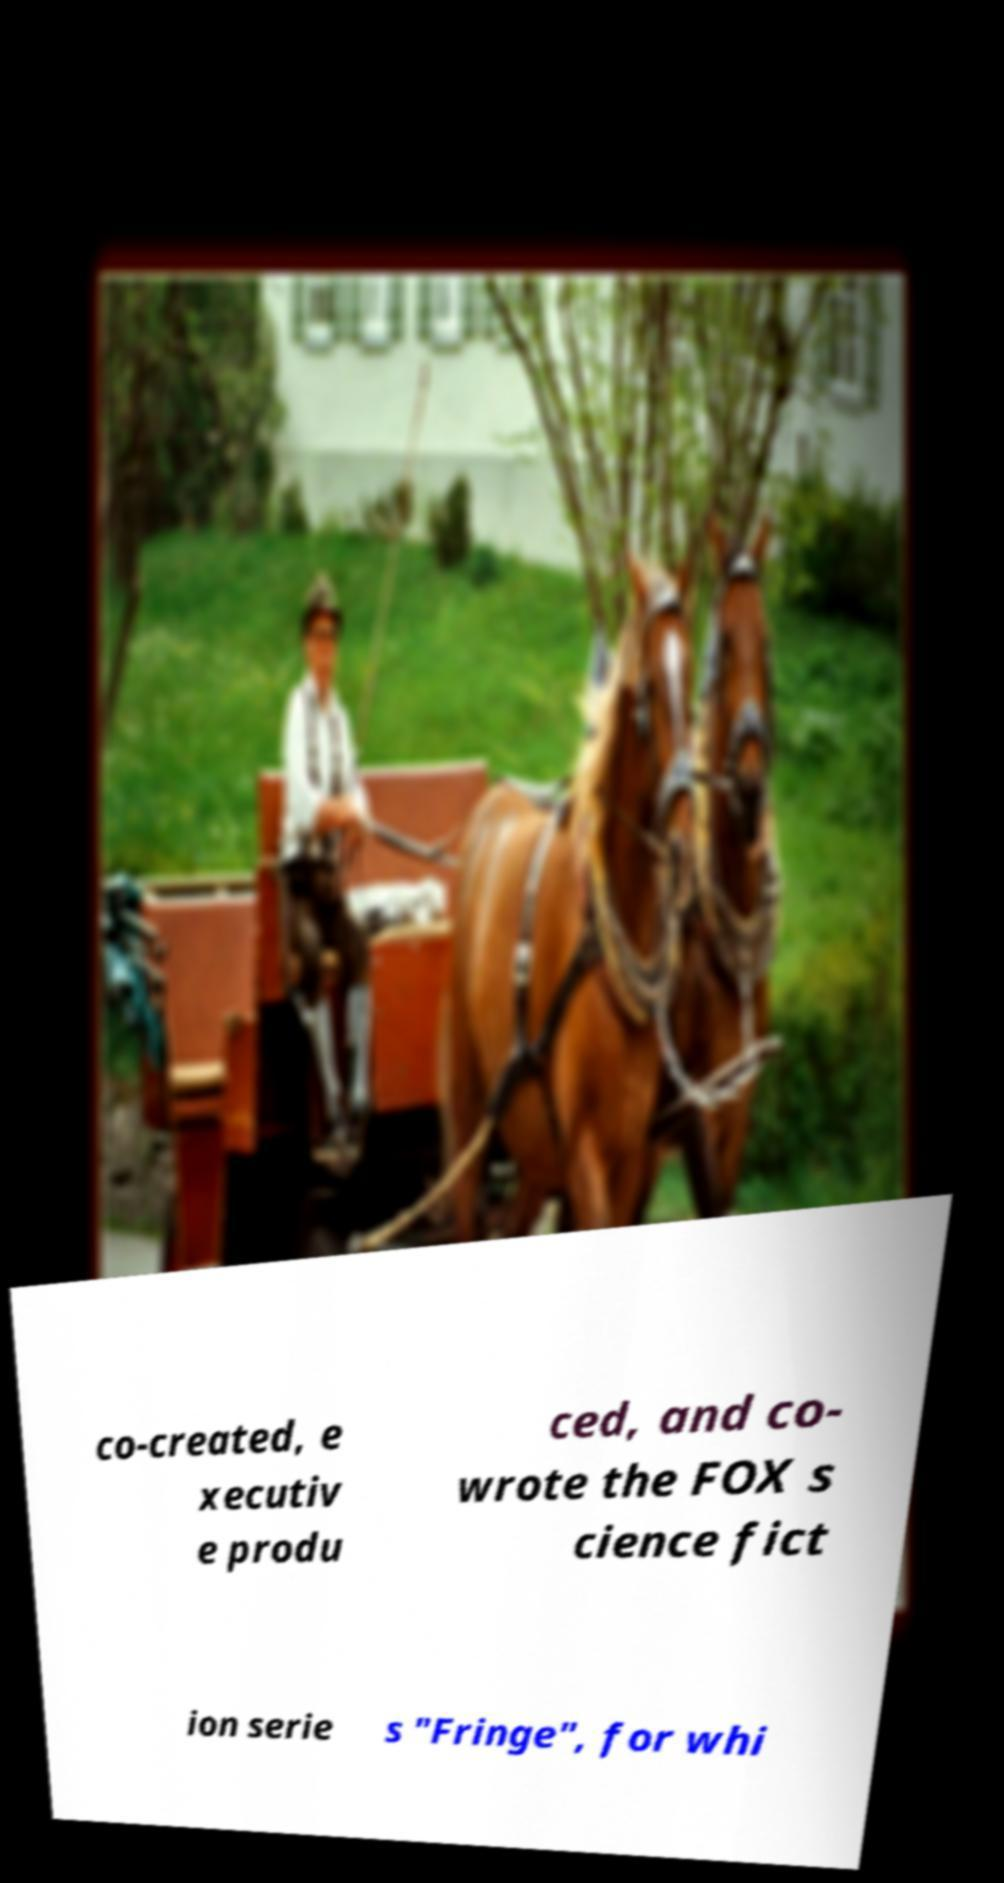Could you assist in decoding the text presented in this image and type it out clearly? co-created, e xecutiv e produ ced, and co- wrote the FOX s cience fict ion serie s "Fringe", for whi 